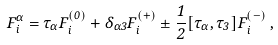<formula> <loc_0><loc_0><loc_500><loc_500>F _ { i } ^ { \alpha } = \tau _ { \alpha } F _ { i } ^ { ( 0 ) } + \delta _ { \alpha 3 } F _ { i } ^ { ( + ) } \pm \frac { 1 } { 2 } [ \tau _ { \alpha } , \tau _ { 3 } ] F _ { i } ^ { ( - ) } \, ,</formula> 